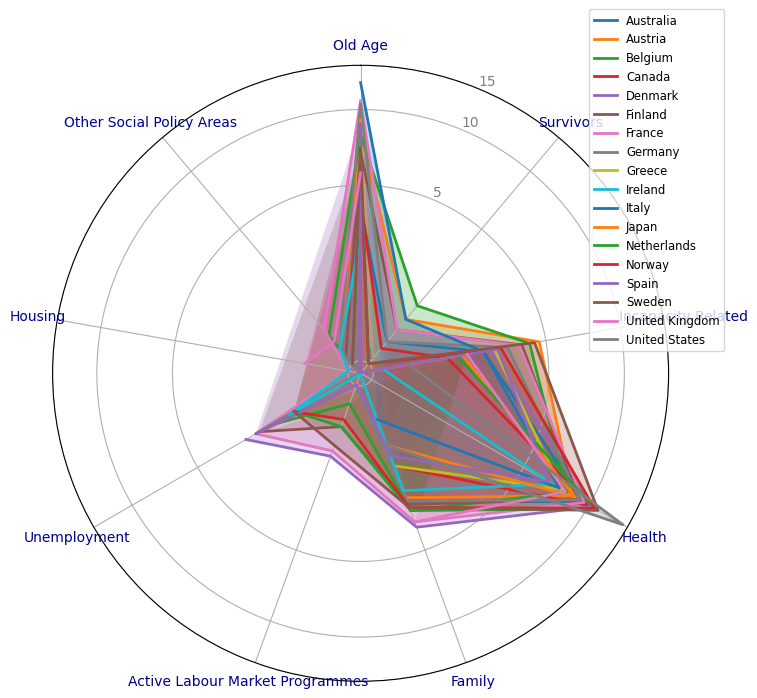What is the country with the highest spending on "Old Age"? To determine the country with the highest spending on "Old Age", look at each chart’s "Old Age" axis, which is the first one from the top (12 o'clock position) and check the highest value marked. From there, identify the corresponding country.
Answer: Greece Compare the spending on "Health" between the United States and Ireland. Which country spends more? Examine the "Health" axis for both the United States and Ireland. The United States has a higher value (14.3) compared to Ireland (6.8).
Answer: United States Which country has the smallest variance in spending across all sectors? Calculate the variance of spending across all sectors for each country by visually analyzing the proximity of values to each other. A radar chart close to a circle represents less variance. By visual inspection, Finland's plot looks the most uniform.
Answer: Finland What is the average spending on "Family" across all countries? Sum all the spending values on "Family" for each country and divide by the number of countries. (3.1 + 3.0 + 3.4 + 2.2 + 4.0 + 3.2 + 3.8 + 3.1 + 2.2 + 2.8 + 1.4 + 1.8 + 3.4 + 3.3 + 2.0 + 3.3 + 3.8 + 1.8) / 18 = 57.4 / 18.
Answer: 3.19 Between France and Sweden, which country spends more on "Incapacity Related"? How much more? Check the "Incapacity Related" sector for both countries. France spends 3.9, while Sweden spends 4.5. The difference is 4.5 - 3.9.
Answer: Sweden, 0.6 Identify the country that spends the most on "Unemployment". Look at the "Unemployment" axis for the highest value. Denmark has the highest spending marked at 3.0.
Answer: Denmark Which country has the highest "Other Social Policy Areas" spending, and what is its value? Check the "Other Social Policy Areas" axis for the peak value. France and Ireland both spend 1.5 each on this sector.
Answer: France and Ireland, 1.5 How does "Housing" spending in the United Kingdom compare to that in the United States? Assess the "Housing" axis for both countries. The United Kingdom spends 1.5, whereas the United States spends 1.3.
Answer: United Kingdom Calculate the total social spending for Denmark across all sectors. Sum the values of all spending sectors for Denmark: 5.2 + 0.8 + 3.0 + 10.3 + 4.0 + 2.0 + 3.0 + 0.8 + 1.0 = 29.1.
Answer: 29.1 What is the rank of Japan in terms of "Health" spending? Sort all countries by their "Health" spending and determine Japan's position. Japan's "Health" spending is 8.6, which ranks behind the United States, Netherlands, and Sweden who spend 14.3, 10.7, and 11.0 respectively.
Answer: 4th 